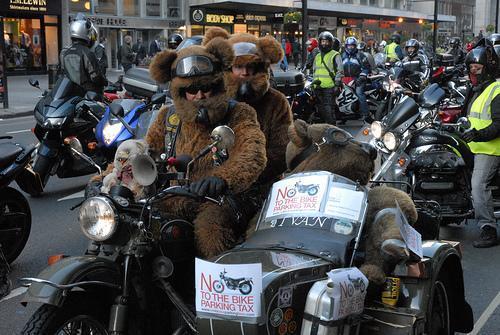How many bears are in the picture?
Give a very brief answer. 3. How many people are there?
Give a very brief answer. 5. How many motorcycles can you see?
Give a very brief answer. 5. How many yellow car in the road?
Give a very brief answer. 0. 